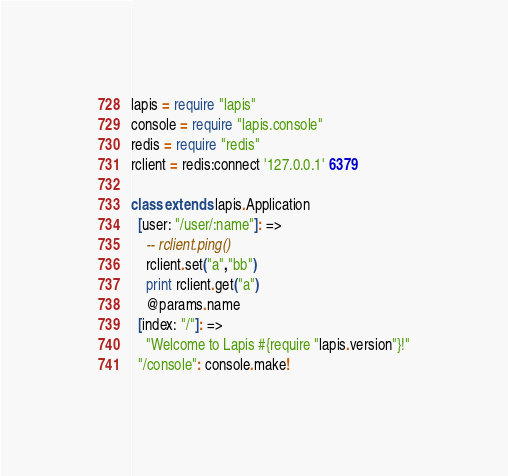Convert code to text. <code><loc_0><loc_0><loc_500><loc_500><_MoonScript_>lapis = require "lapis"
console = require "lapis.console"
redis = require "redis"
rclient = redis:connect '127.0.0.1' 6379

class extends lapis.Application
  [user: "/user/:name"]: =>    
    -- rclient.ping()
    rclient.set("a","bb")
    print rclient.get("a")
    @params.name
  [index: "/"]: =>
    "Welcome to Lapis #{require "lapis.version"}!"
  "/console": console.make!
</code> 